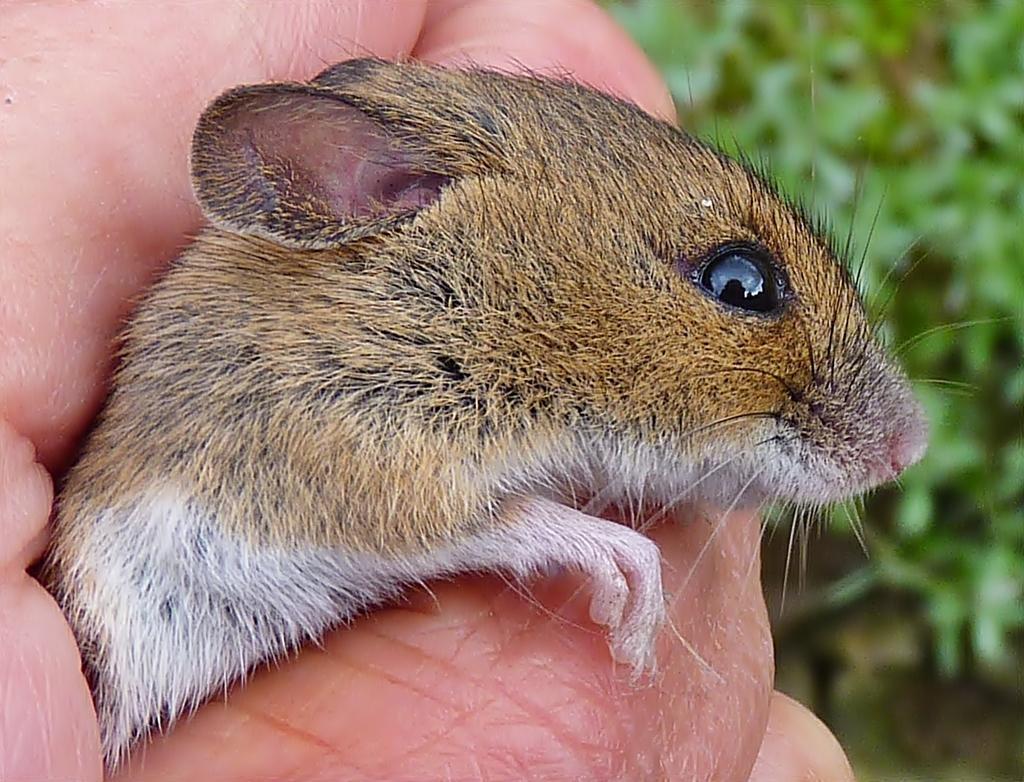Please provide a concise description of this image. This is a zoomed in picture. In the center we can see the hand of a person holding an animal. In the background we can see the green color objects seems to be the plants. 